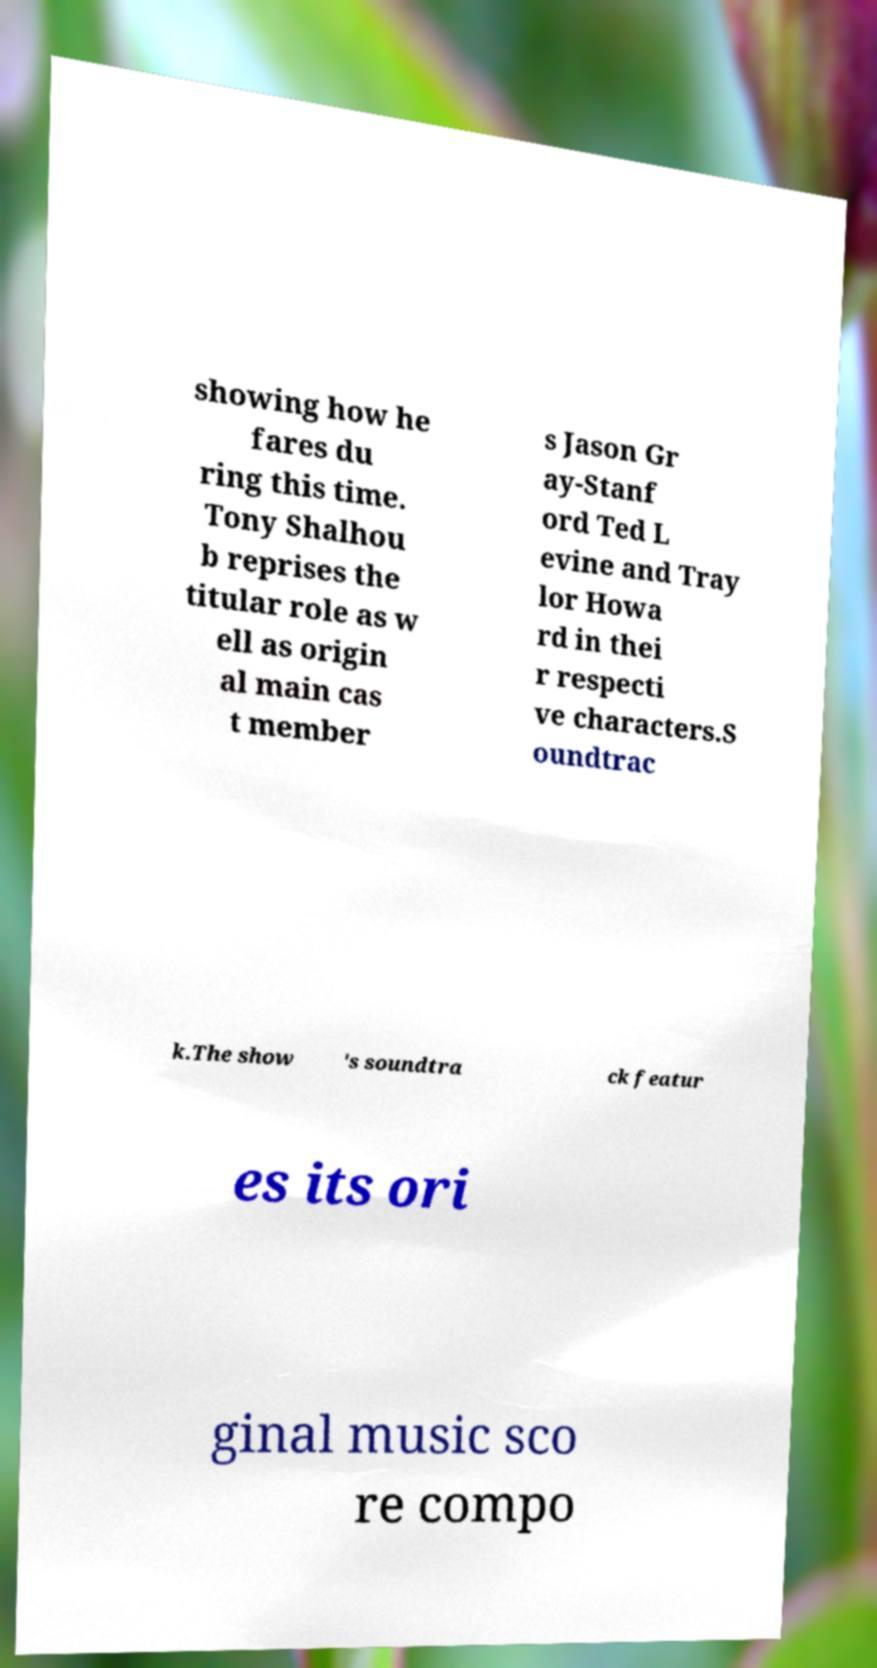There's text embedded in this image that I need extracted. Can you transcribe it verbatim? showing how he fares du ring this time. Tony Shalhou b reprises the titular role as w ell as origin al main cas t member s Jason Gr ay-Stanf ord Ted L evine and Tray lor Howa rd in thei r respecti ve characters.S oundtrac k.The show 's soundtra ck featur es its ori ginal music sco re compo 